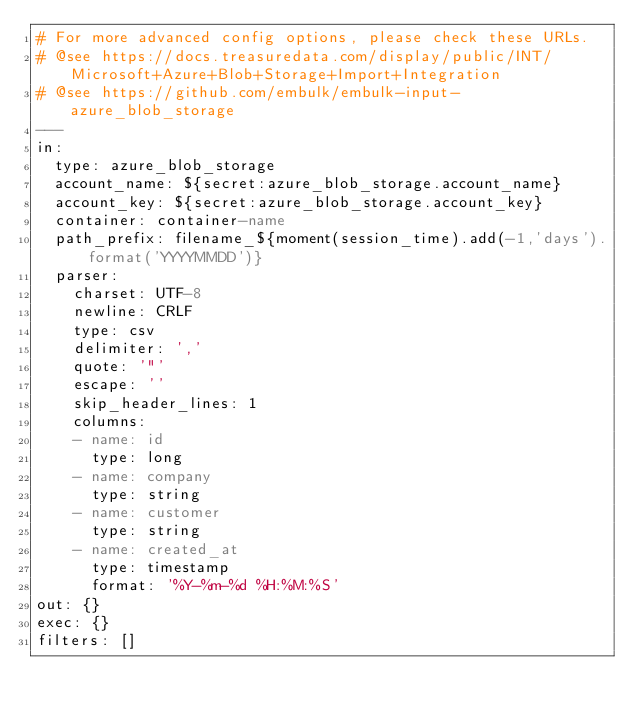<code> <loc_0><loc_0><loc_500><loc_500><_YAML_># For more advanced config options, please check these URLs.
# @see https://docs.treasuredata.com/display/public/INT/Microsoft+Azure+Blob+Storage+Import+Integration
# @see https://github.com/embulk/embulk-input-azure_blob_storage
---
in:
  type: azure_blob_storage
  account_name: ${secret:azure_blob_storage.account_name}
  account_key: ${secret:azure_blob_storage.account_key}
  container: container-name
  path_prefix: filename_${moment(session_time).add(-1,'days').format('YYYYMMDD')}
  parser:
    charset: UTF-8
    newline: CRLF
    type: csv
    delimiter: ','
    quote: '"'
    escape: ''
    skip_header_lines: 1
    columns:
    - name: id
      type: long
    - name: company
      type: string
    - name: customer
      type: string
    - name: created_at
      type: timestamp
      format: '%Y-%m-%d %H:%M:%S'
out: {}
exec: {}
filters: []
</code> 